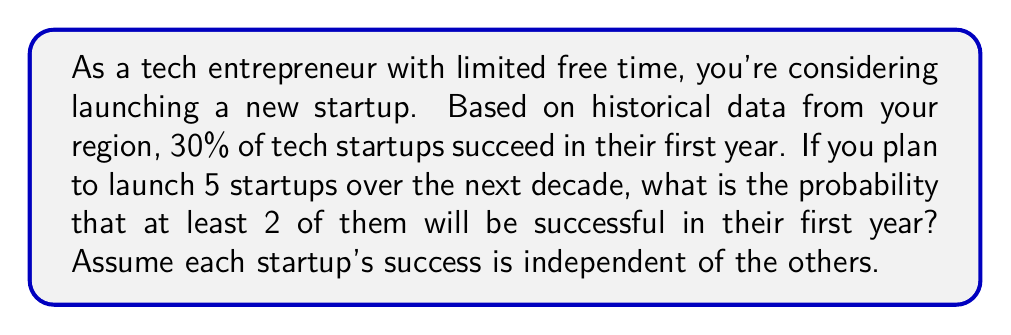Solve this math problem. Let's approach this step-by-step using the binomial probability distribution:

1) We can model this scenario as a binomial distribution with the following parameters:
   $n = 5$ (number of trials/startups)
   $p = 0.30$ (probability of success for each startup)
   $X$ = number of successful startups

2) We need to find $P(X \geq 2)$, which is equivalent to $1 - P(X < 2)$ or $1 - [P(X=0) + P(X=1)]$

3) The binomial probability formula is:

   $$P(X = k) = \binom{n}{k} p^k (1-p)^{n-k}$$

   Where $\binom{n}{k}$ is the binomial coefficient.

4) Let's calculate $P(X=0)$ and $P(X=1)$:

   $P(X=0) = \binom{5}{0} (0.30)^0 (0.70)^5 = 1 \cdot 1 \cdot 0.16807 = 0.16807$

   $P(X=1) = \binom{5}{1} (0.30)^1 (0.70)^4 = 5 \cdot 0.30 \cdot 0.2401 = 0.36015$

5) Now, we can calculate $P(X \geq 2)$:

   $P(X \geq 2) = 1 - [P(X=0) + P(X=1)]$
                $= 1 - (0.16807 + 0.36015)$
                $= 1 - 0.52822$
                $= 0.47178$

Therefore, the probability of at least 2 out of 5 startups being successful is approximately 0.47178 or 47.178%.
Answer: The probability that at least 2 out of 5 startups will be successful in their first year is approximately 0.47178 or 47.178%. 